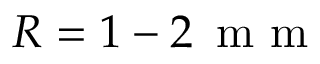Convert formula to latex. <formula><loc_0><loc_0><loc_500><loc_500>R = 1 - 2 \, m m</formula> 